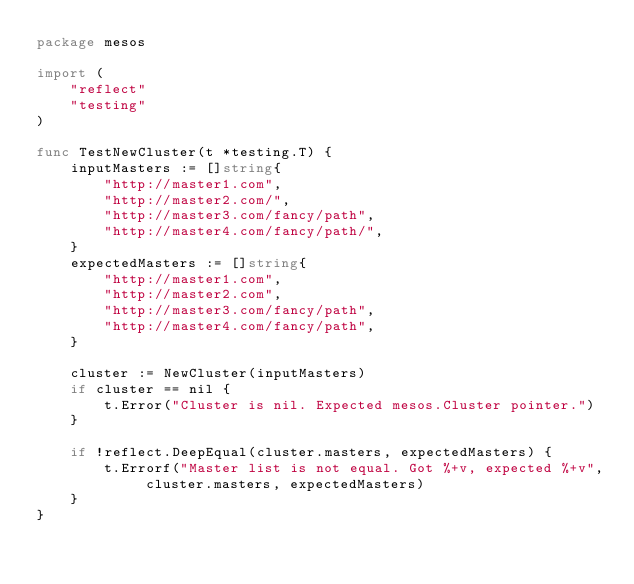Convert code to text. <code><loc_0><loc_0><loc_500><loc_500><_Go_>package mesos

import (
	"reflect"
	"testing"
)

func TestNewCluster(t *testing.T) {
	inputMasters := []string{
		"http://master1.com",
		"http://master2.com/",
		"http://master3.com/fancy/path",
		"http://master4.com/fancy/path/",
	}
	expectedMasters := []string{
		"http://master1.com",
		"http://master2.com",
		"http://master3.com/fancy/path",
		"http://master4.com/fancy/path",
	}

	cluster := NewCluster(inputMasters)
	if cluster == nil {
		t.Error("Cluster is nil. Expected mesos.Cluster pointer.")
	}

	if !reflect.DeepEqual(cluster.masters, expectedMasters) {
		t.Errorf("Master list is not equal. Got %+v, expected %+v", cluster.masters, expectedMasters)
	}
}
</code> 